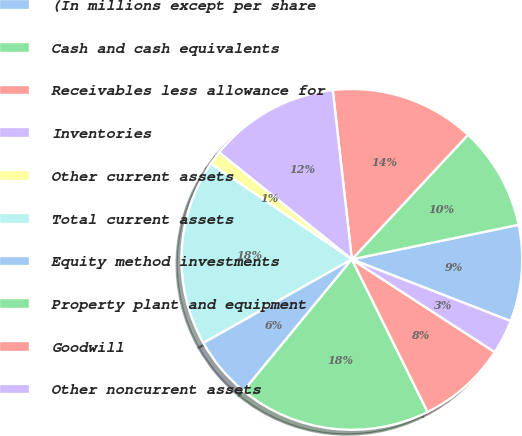Convert chart to OTSL. <chart><loc_0><loc_0><loc_500><loc_500><pie_chart><fcel>(In millions except per share<fcel>Cash and cash equivalents<fcel>Receivables less allowance for<fcel>Inventories<fcel>Other current assets<fcel>Total current assets<fcel>Equity method investments<fcel>Property plant and equipment<fcel>Goodwill<fcel>Other noncurrent assets<nl><fcel>9.15%<fcel>9.8%<fcel>13.73%<fcel>12.42%<fcel>1.31%<fcel>17.65%<fcel>5.88%<fcel>18.3%<fcel>8.5%<fcel>3.27%<nl></chart> 